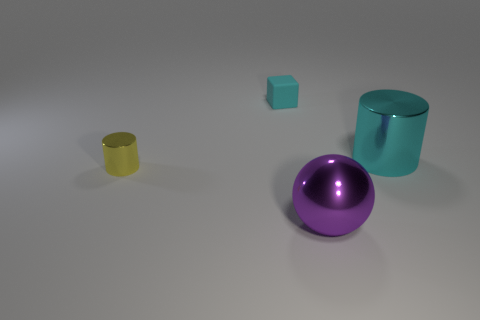How many tiny cyan matte objects are in front of the thing that is behind the thing to the right of the large purple metallic object?
Your answer should be compact. 0. There is a large cyan object that is the same shape as the yellow thing; what material is it?
Your answer should be very brief. Metal. Is there any other thing that is the same material as the yellow thing?
Ensure brevity in your answer.  Yes. The cylinder that is to the right of the big shiny ball is what color?
Offer a very short reply. Cyan. Do the cyan cylinder and the big thing that is in front of the tiny metallic cylinder have the same material?
Offer a very short reply. Yes. What material is the big purple sphere?
Offer a very short reply. Metal. What is the shape of the large purple thing that is the same material as the tiny yellow cylinder?
Provide a succinct answer. Sphere. What number of other things are the same shape as the big cyan thing?
Give a very brief answer. 1. There is a yellow cylinder; what number of tiny cyan rubber cubes are in front of it?
Keep it short and to the point. 0. There is a metallic cylinder that is in front of the large shiny cylinder; does it have the same size as the metal cylinder that is on the right side of the purple ball?
Ensure brevity in your answer.  No. 